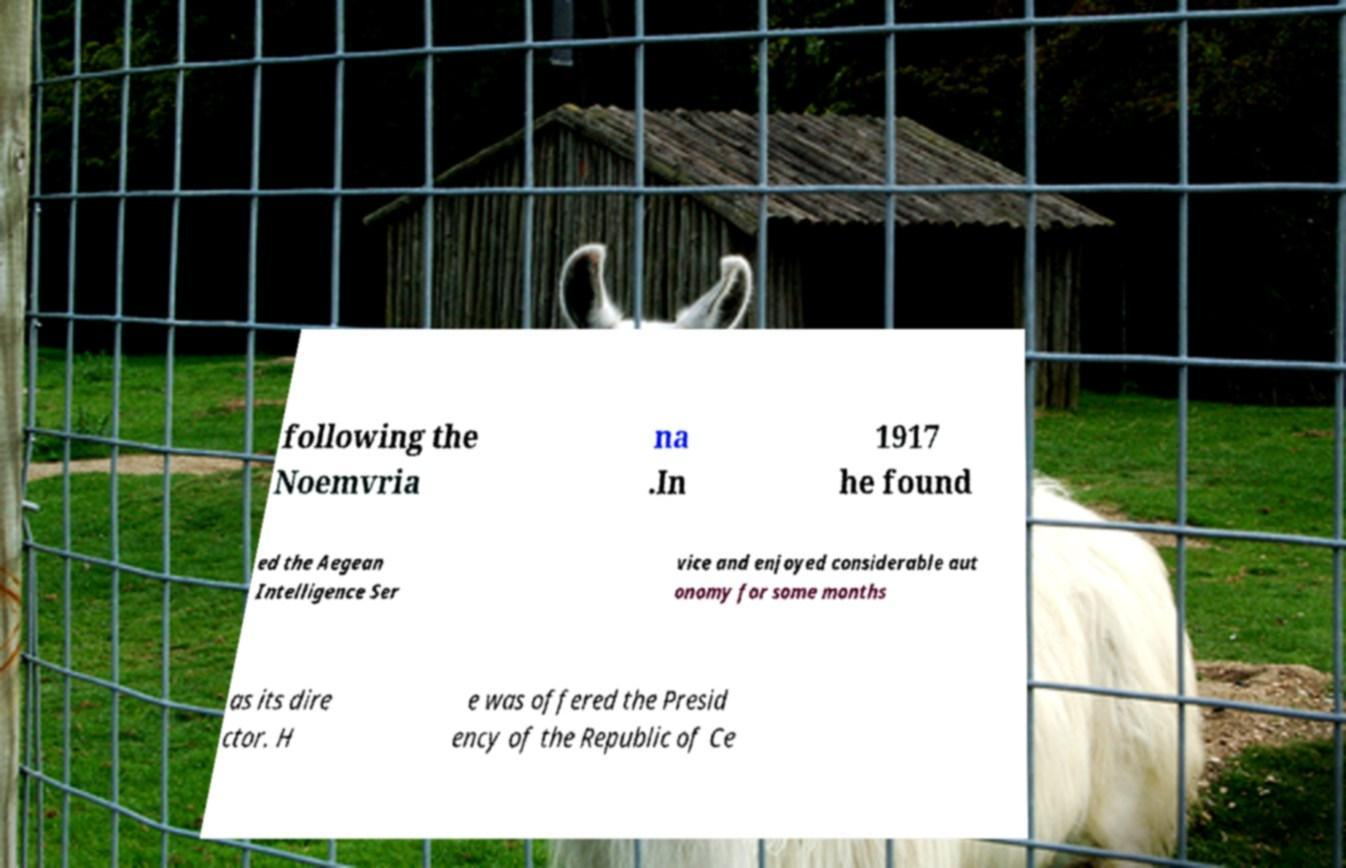Please read and relay the text visible in this image. What does it say? following the Noemvria na .In 1917 he found ed the Aegean Intelligence Ser vice and enjoyed considerable aut onomy for some months as its dire ctor. H e was offered the Presid ency of the Republic of Ce 